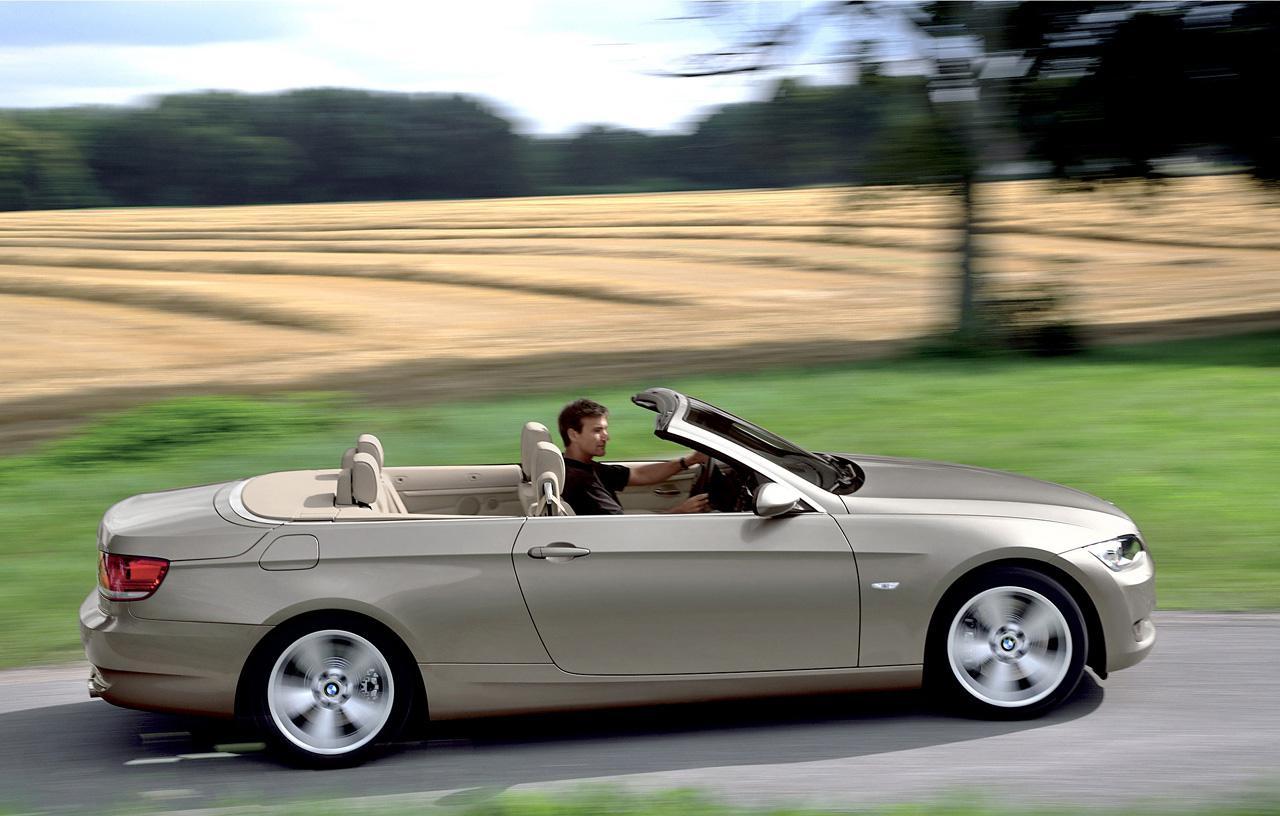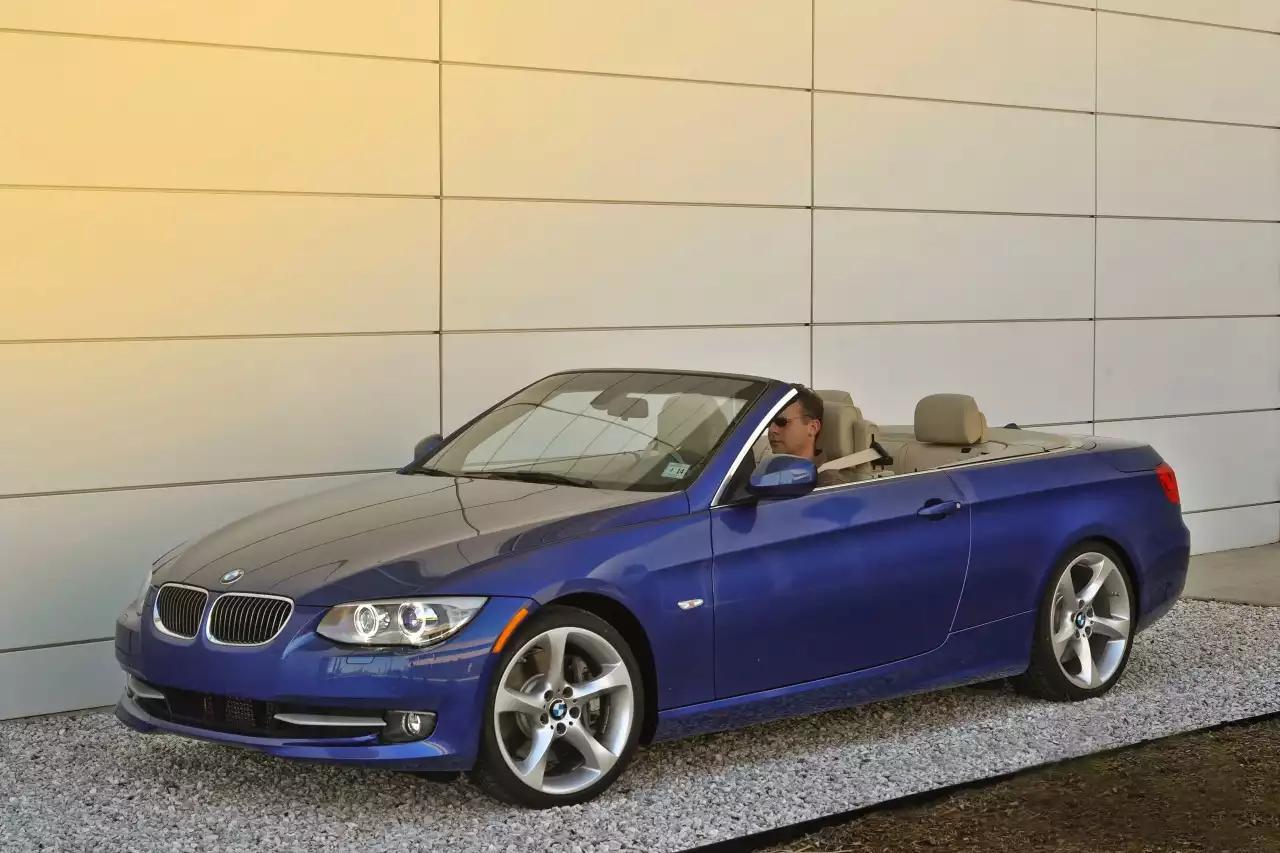The first image is the image on the left, the second image is the image on the right. Analyze the images presented: Is the assertion "An image shows a forward-facing royal blue convertible with some type of wall behind it." valid? Answer yes or no. Yes. The first image is the image on the left, the second image is the image on the right. Evaluate the accuracy of this statement regarding the images: "AN image contains a blue convertible sports car.". Is it true? Answer yes or no. Yes. 